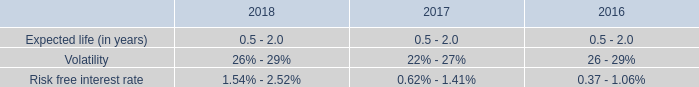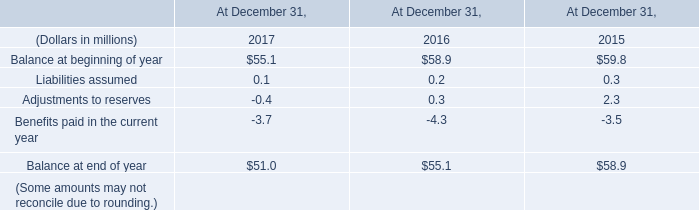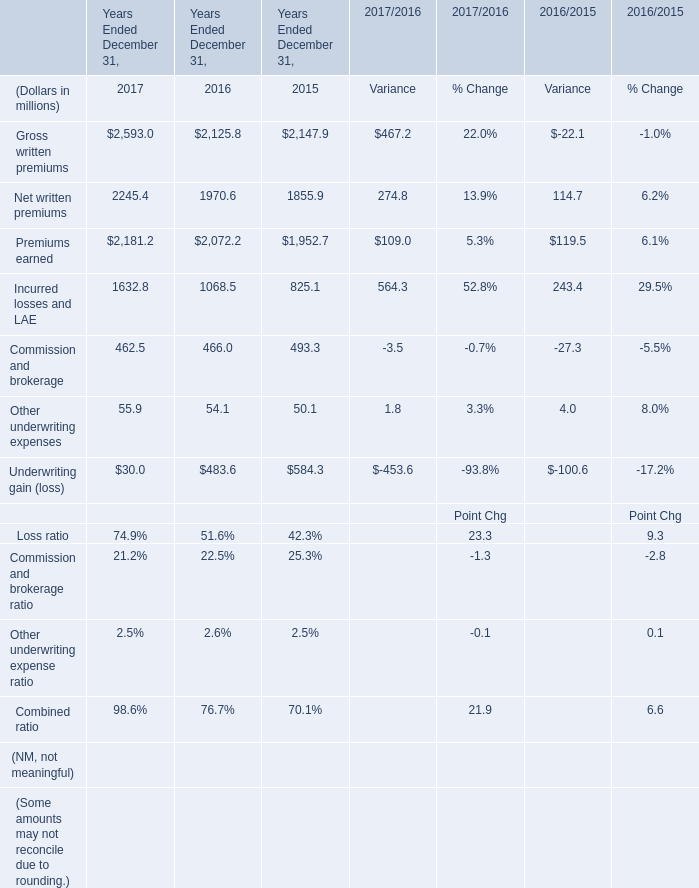What is the ratio of Premiums earned in Table 2 to the Balance at end of year in Table 1 in 2017? 
Computations: (2181.2 / 51)
Answer: 42.76863. 